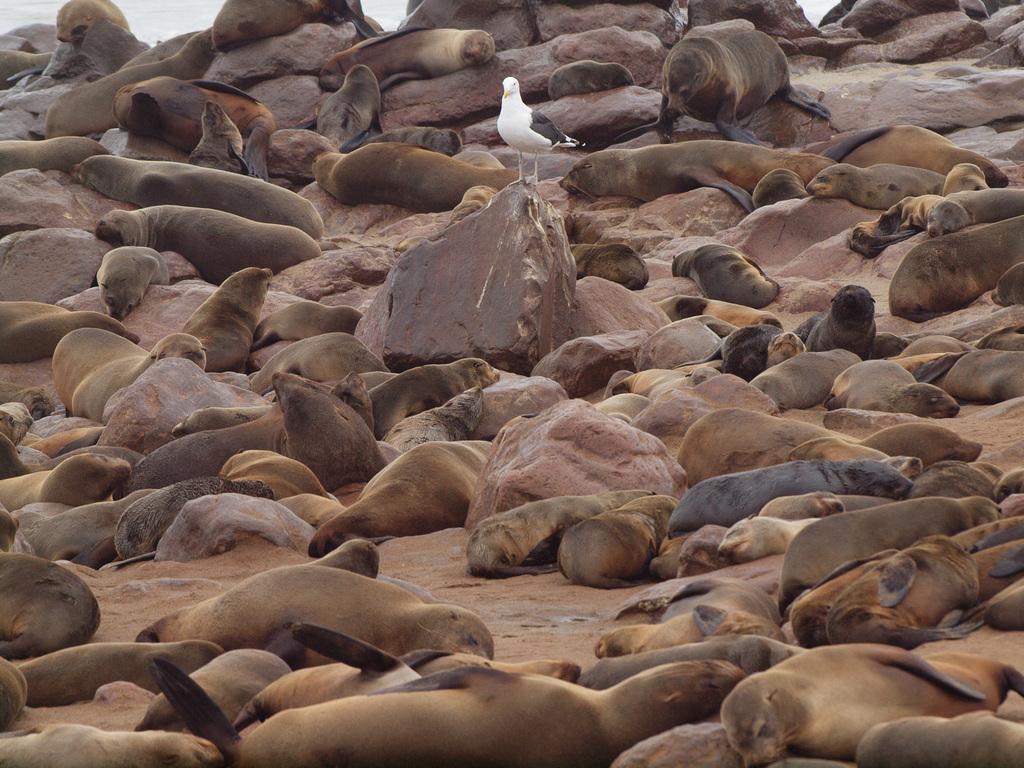In one or two sentences, can you explain what this image depicts? In this image we can see rocks and seals. Middle of the image there is a rock. Above that rock there is a bird. 